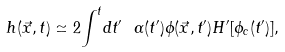<formula> <loc_0><loc_0><loc_500><loc_500>h ( \vec { x } , t ) \simeq 2 { \int } ^ { t } d t ^ { \prime } \ \alpha ( t ^ { \prime } ) \phi ( \vec { x } , t ^ { \prime } ) H ^ { \prime } [ \phi _ { c } ( t ^ { \prime } ) ] ,</formula> 